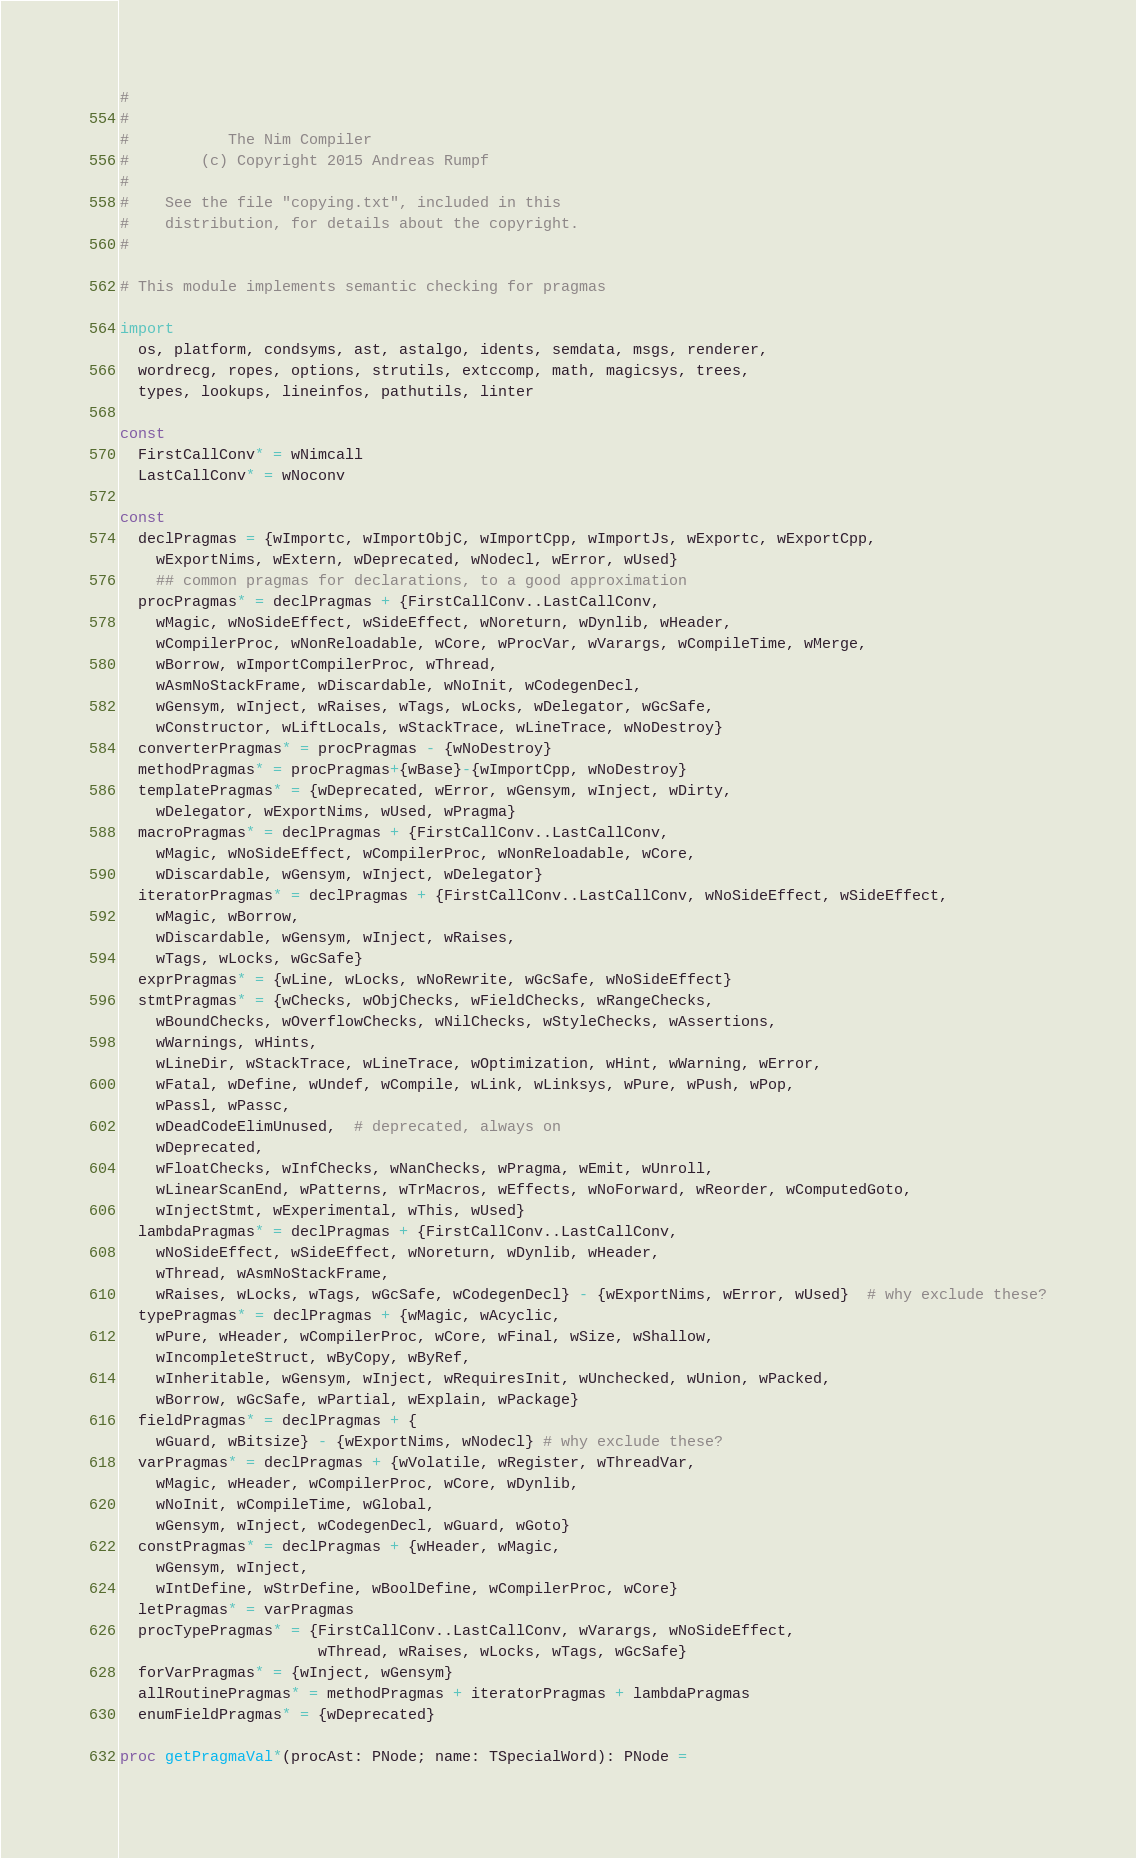Convert code to text. <code><loc_0><loc_0><loc_500><loc_500><_Nim_>#
#
#           The Nim Compiler
#        (c) Copyright 2015 Andreas Rumpf
#
#    See the file "copying.txt", included in this
#    distribution, for details about the copyright.
#

# This module implements semantic checking for pragmas

import
  os, platform, condsyms, ast, astalgo, idents, semdata, msgs, renderer,
  wordrecg, ropes, options, strutils, extccomp, math, magicsys, trees,
  types, lookups, lineinfos, pathutils, linter

const
  FirstCallConv* = wNimcall
  LastCallConv* = wNoconv

const
  declPragmas = {wImportc, wImportObjC, wImportCpp, wImportJs, wExportc, wExportCpp,
    wExportNims, wExtern, wDeprecated, wNodecl, wError, wUsed}
    ## common pragmas for declarations, to a good approximation
  procPragmas* = declPragmas + {FirstCallConv..LastCallConv,
    wMagic, wNoSideEffect, wSideEffect, wNoreturn, wDynlib, wHeader,
    wCompilerProc, wNonReloadable, wCore, wProcVar, wVarargs, wCompileTime, wMerge,
    wBorrow, wImportCompilerProc, wThread,
    wAsmNoStackFrame, wDiscardable, wNoInit, wCodegenDecl,
    wGensym, wInject, wRaises, wTags, wLocks, wDelegator, wGcSafe,
    wConstructor, wLiftLocals, wStackTrace, wLineTrace, wNoDestroy}
  converterPragmas* = procPragmas - {wNoDestroy}
  methodPragmas* = procPragmas+{wBase}-{wImportCpp, wNoDestroy}
  templatePragmas* = {wDeprecated, wError, wGensym, wInject, wDirty,
    wDelegator, wExportNims, wUsed, wPragma}
  macroPragmas* = declPragmas + {FirstCallConv..LastCallConv,
    wMagic, wNoSideEffect, wCompilerProc, wNonReloadable, wCore,
    wDiscardable, wGensym, wInject, wDelegator}
  iteratorPragmas* = declPragmas + {FirstCallConv..LastCallConv, wNoSideEffect, wSideEffect,
    wMagic, wBorrow,
    wDiscardable, wGensym, wInject, wRaises,
    wTags, wLocks, wGcSafe}
  exprPragmas* = {wLine, wLocks, wNoRewrite, wGcSafe, wNoSideEffect}
  stmtPragmas* = {wChecks, wObjChecks, wFieldChecks, wRangeChecks,
    wBoundChecks, wOverflowChecks, wNilChecks, wStyleChecks, wAssertions,
    wWarnings, wHints,
    wLineDir, wStackTrace, wLineTrace, wOptimization, wHint, wWarning, wError,
    wFatal, wDefine, wUndef, wCompile, wLink, wLinksys, wPure, wPush, wPop,
    wPassl, wPassc,
    wDeadCodeElimUnused,  # deprecated, always on
    wDeprecated,
    wFloatChecks, wInfChecks, wNanChecks, wPragma, wEmit, wUnroll,
    wLinearScanEnd, wPatterns, wTrMacros, wEffects, wNoForward, wReorder, wComputedGoto,
    wInjectStmt, wExperimental, wThis, wUsed}
  lambdaPragmas* = declPragmas + {FirstCallConv..LastCallConv,
    wNoSideEffect, wSideEffect, wNoreturn, wDynlib, wHeader,
    wThread, wAsmNoStackFrame,
    wRaises, wLocks, wTags, wGcSafe, wCodegenDecl} - {wExportNims, wError, wUsed}  # why exclude these?
  typePragmas* = declPragmas + {wMagic, wAcyclic,
    wPure, wHeader, wCompilerProc, wCore, wFinal, wSize, wShallow,
    wIncompleteStruct, wByCopy, wByRef,
    wInheritable, wGensym, wInject, wRequiresInit, wUnchecked, wUnion, wPacked,
    wBorrow, wGcSafe, wPartial, wExplain, wPackage}
  fieldPragmas* = declPragmas + {
    wGuard, wBitsize} - {wExportNims, wNodecl} # why exclude these?
  varPragmas* = declPragmas + {wVolatile, wRegister, wThreadVar,
    wMagic, wHeader, wCompilerProc, wCore, wDynlib,
    wNoInit, wCompileTime, wGlobal,
    wGensym, wInject, wCodegenDecl, wGuard, wGoto}
  constPragmas* = declPragmas + {wHeader, wMagic,
    wGensym, wInject,
    wIntDefine, wStrDefine, wBoolDefine, wCompilerProc, wCore}
  letPragmas* = varPragmas
  procTypePragmas* = {FirstCallConv..LastCallConv, wVarargs, wNoSideEffect,
                      wThread, wRaises, wLocks, wTags, wGcSafe}
  forVarPragmas* = {wInject, wGensym}
  allRoutinePragmas* = methodPragmas + iteratorPragmas + lambdaPragmas
  enumFieldPragmas* = {wDeprecated}

proc getPragmaVal*(procAst: PNode; name: TSpecialWord): PNode =</code> 